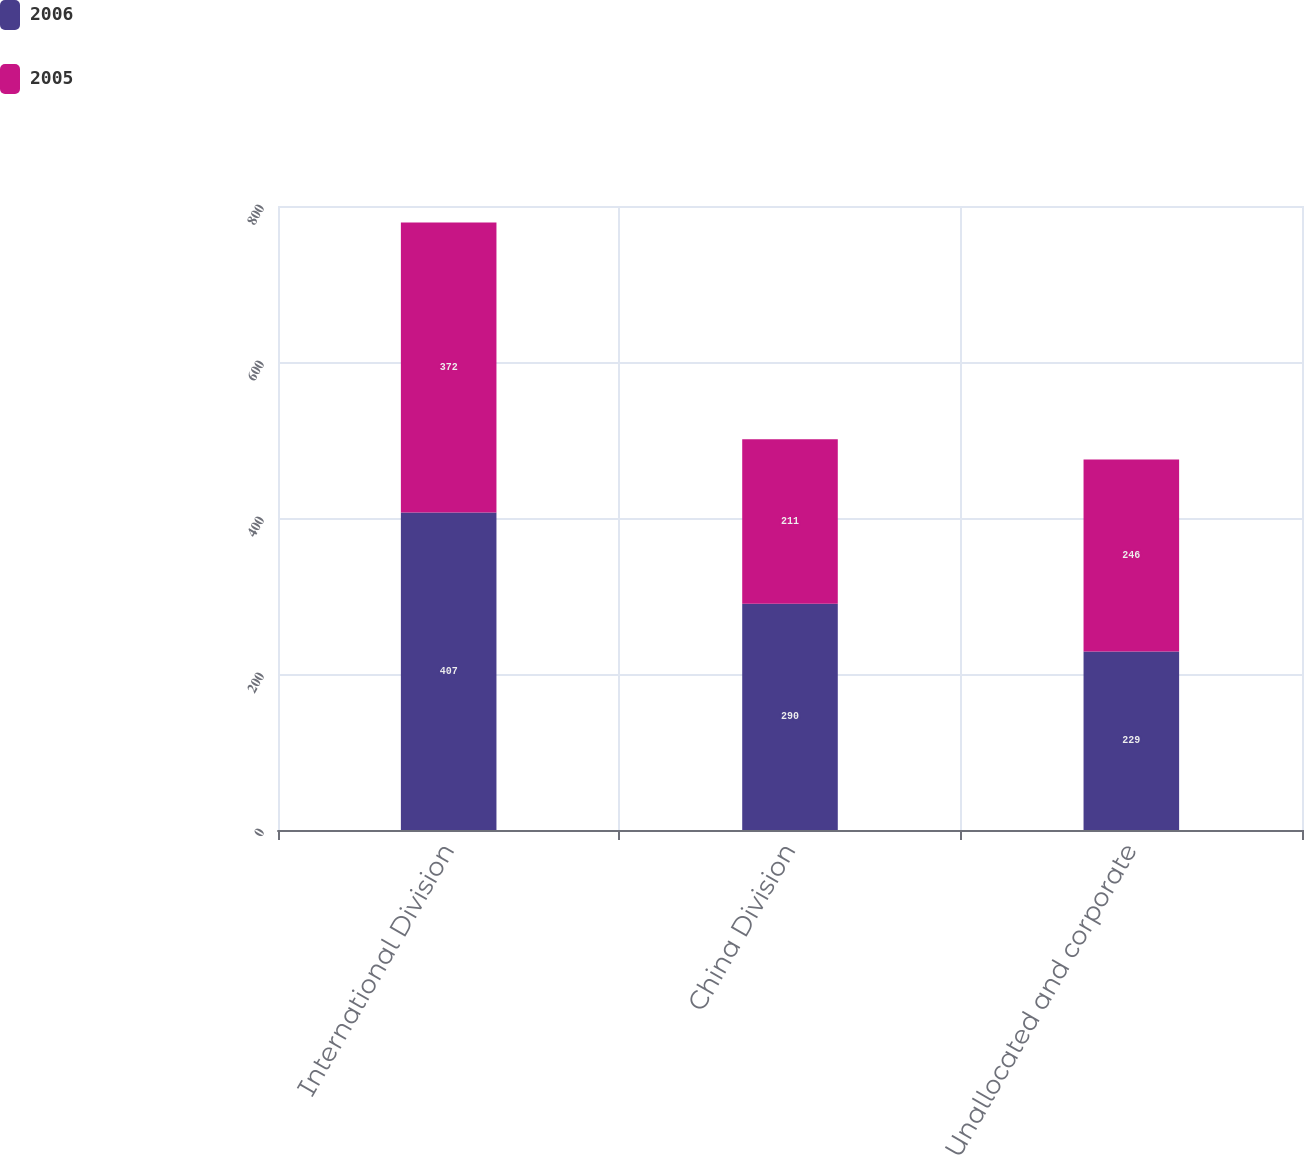Convert chart to OTSL. <chart><loc_0><loc_0><loc_500><loc_500><stacked_bar_chart><ecel><fcel>International Division<fcel>China Division<fcel>Unallocated and corporate<nl><fcel>2006<fcel>407<fcel>290<fcel>229<nl><fcel>2005<fcel>372<fcel>211<fcel>246<nl></chart> 